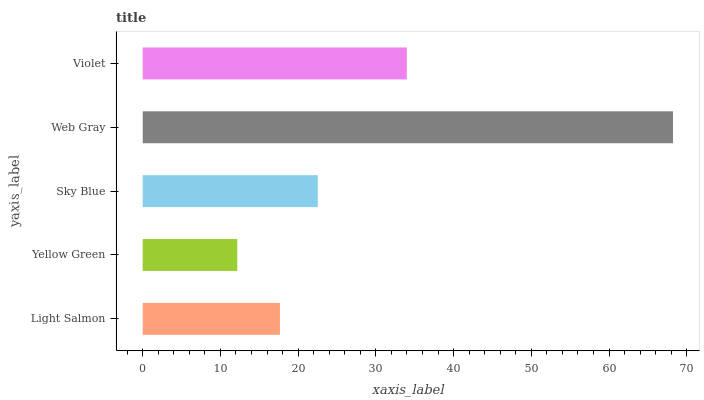Is Yellow Green the minimum?
Answer yes or no. Yes. Is Web Gray the maximum?
Answer yes or no. Yes. Is Sky Blue the minimum?
Answer yes or no. No. Is Sky Blue the maximum?
Answer yes or no. No. Is Sky Blue greater than Yellow Green?
Answer yes or no. Yes. Is Yellow Green less than Sky Blue?
Answer yes or no. Yes. Is Yellow Green greater than Sky Blue?
Answer yes or no. No. Is Sky Blue less than Yellow Green?
Answer yes or no. No. Is Sky Blue the high median?
Answer yes or no. Yes. Is Sky Blue the low median?
Answer yes or no. Yes. Is Light Salmon the high median?
Answer yes or no. No. Is Web Gray the low median?
Answer yes or no. No. 